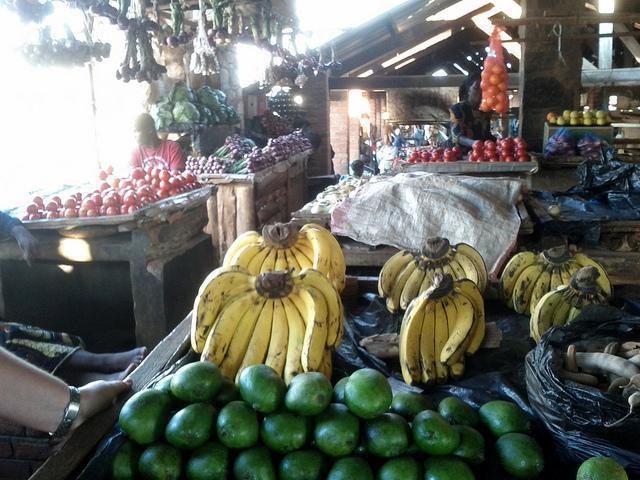What color is the fruit located under the bananas?
Choose the right answer and clarify with the format: 'Answer: answer
Rationale: rationale.'
Options: Pink, red, purple, green. Answer: green.
Rationale: The limes are green which is the color they are supposed to be. 